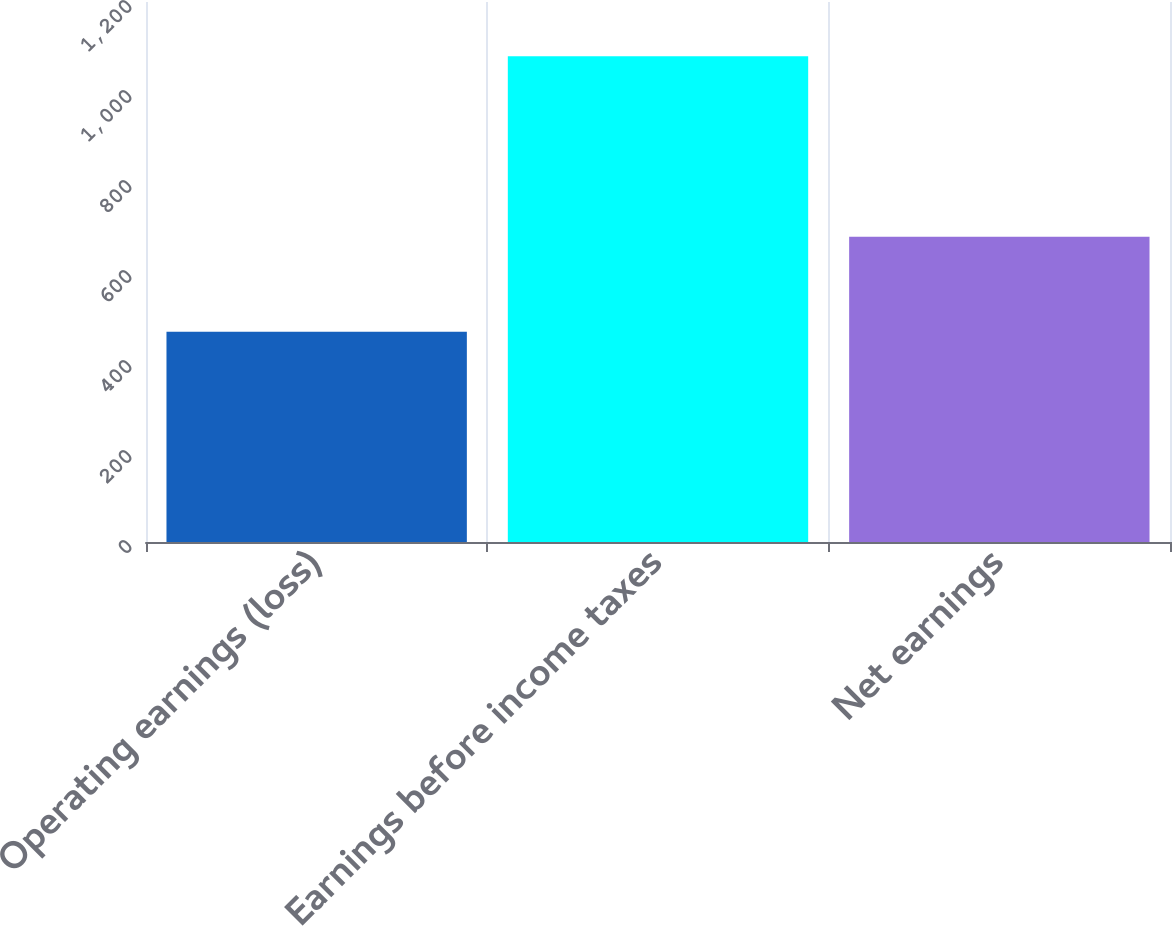Convert chart. <chart><loc_0><loc_0><loc_500><loc_500><bar_chart><fcel>Operating earnings (loss)<fcel>Earnings before income taxes<fcel>Net earnings<nl><fcel>467.3<fcel>1079.4<fcel>678.5<nl></chart> 